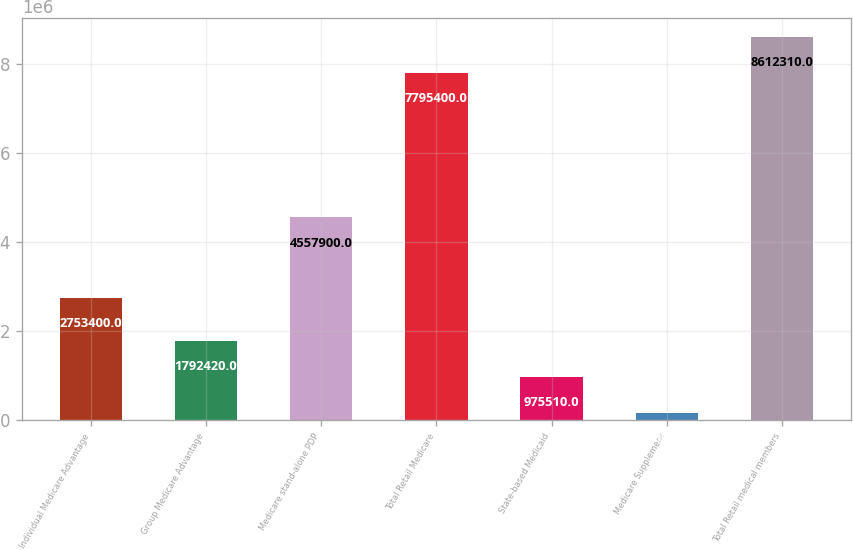Convert chart to OTSL. <chart><loc_0><loc_0><loc_500><loc_500><bar_chart><fcel>Individual Medicare Advantage<fcel>Group Medicare Advantage<fcel>Medicare stand-alone PDP<fcel>Total Retail Medicare<fcel>State-based Medicaid<fcel>Medicare Supplement<fcel>Total Retail medical members<nl><fcel>2.7534e+06<fcel>1.79242e+06<fcel>4.5579e+06<fcel>7.7954e+06<fcel>975510<fcel>158600<fcel>8.61231e+06<nl></chart> 